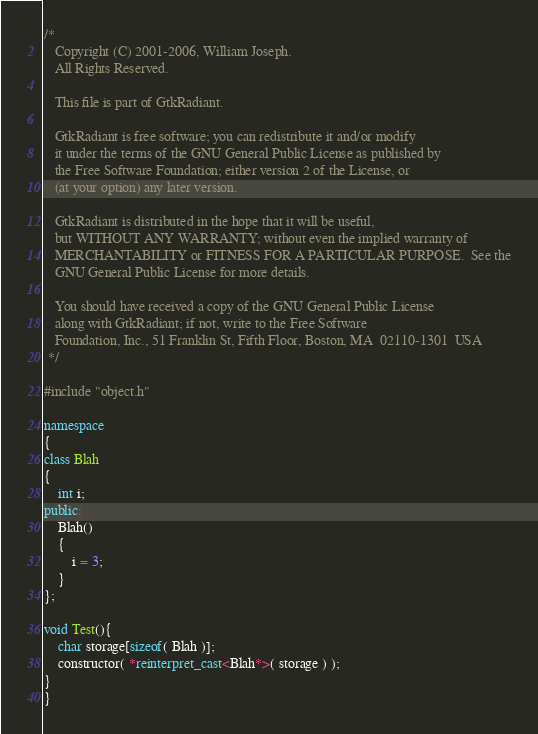<code> <loc_0><loc_0><loc_500><loc_500><_C++_>/*
   Copyright (C) 2001-2006, William Joseph.
   All Rights Reserved.

   This file is part of GtkRadiant.

   GtkRadiant is free software; you can redistribute it and/or modify
   it under the terms of the GNU General Public License as published by
   the Free Software Foundation; either version 2 of the License, or
   (at your option) any later version.

   GtkRadiant is distributed in the hope that it will be useful,
   but WITHOUT ANY WARRANTY; without even the implied warranty of
   MERCHANTABILITY or FITNESS FOR A PARTICULAR PURPOSE.  See the
   GNU General Public License for more details.

   You should have received a copy of the GNU General Public License
   along with GtkRadiant; if not, write to the Free Software
   Foundation, Inc., 51 Franklin St, Fifth Floor, Boston, MA  02110-1301  USA
 */

#include "object.h"

namespace
{
class Blah
{
	int i;
public:
	Blah()
	{
		i = 3;
	}
};

void Test(){
	char storage[sizeof( Blah )];
	constructor( *reinterpret_cast<Blah*>( storage ) );
}
}</code> 